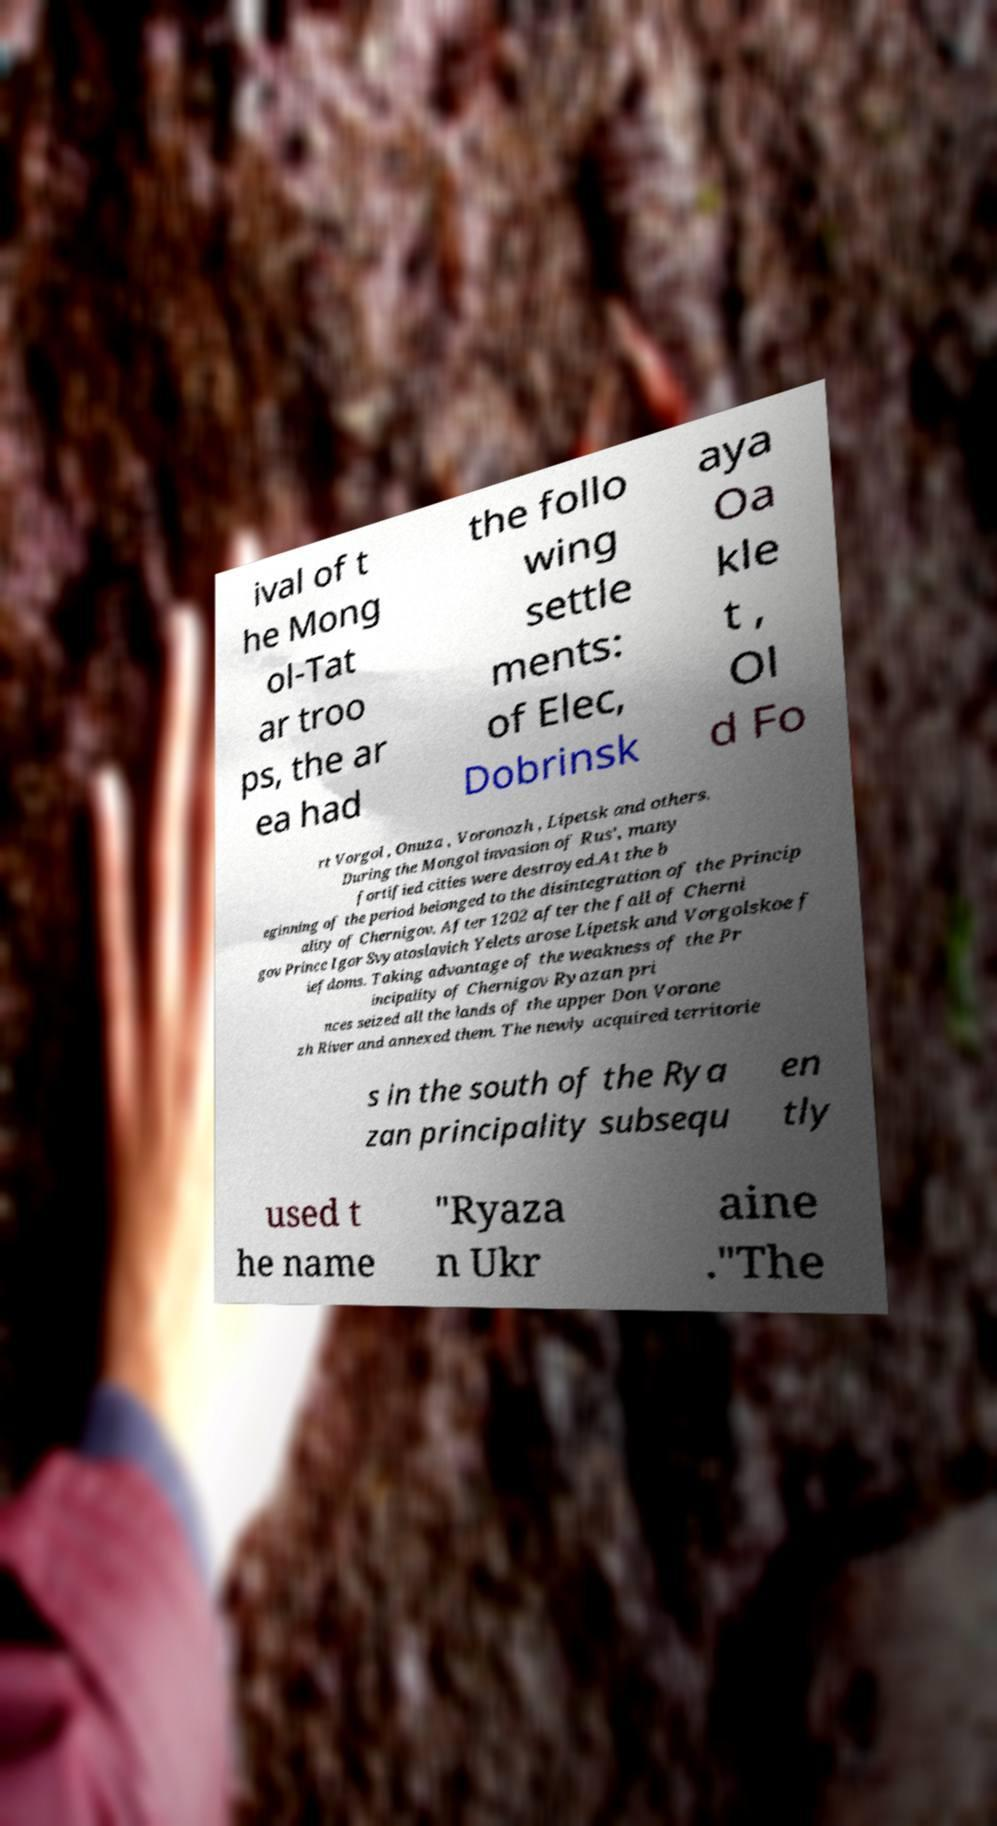There's text embedded in this image that I need extracted. Can you transcribe it verbatim? ival of t he Mong ol-Tat ar troo ps, the ar ea had the follo wing settle ments: of Elec, Dobrinsk aya Oa kle t , Ol d Fo rt Vorgol , Onuza , Voronozh , Lipetsk and others. During the Mongol invasion of Rus', many fortified cities were destroyed.At the b eginning of the period belonged to the disintegration of the Princip ality of Chernigov. After 1202 after the fall of Cherni gov Prince Igor Svyatoslavich Yelets arose Lipetsk and Vorgolskoe f iefdoms. Taking advantage of the weakness of the Pr incipality of Chernigov Ryazan pri nces seized all the lands of the upper Don Vorone zh River and annexed them. The newly acquired territorie s in the south of the Rya zan principality subsequ en tly used t he name "Ryaza n Ukr aine ."The 